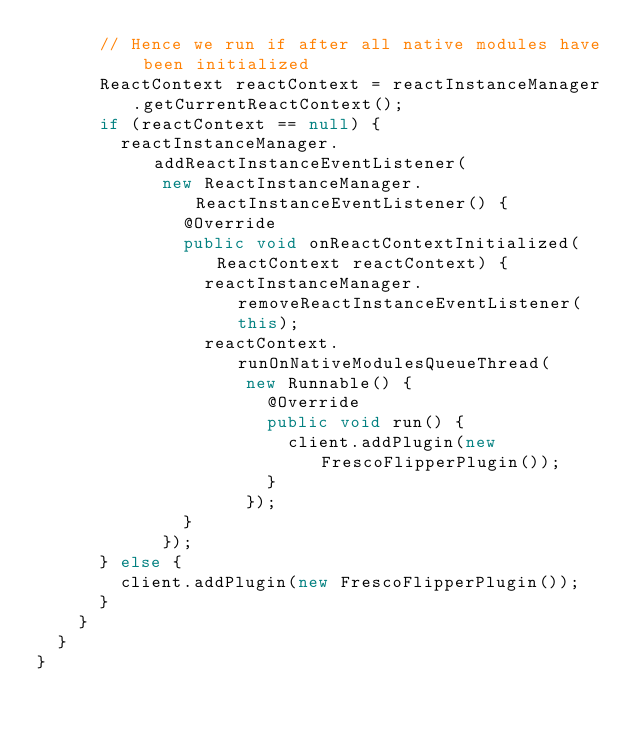Convert code to text. <code><loc_0><loc_0><loc_500><loc_500><_Java_>      // Hence we run if after all native modules have been initialized
      ReactContext reactContext = reactInstanceManager.getCurrentReactContext();
      if (reactContext == null) {
        reactInstanceManager.addReactInstanceEventListener(
            new ReactInstanceManager.ReactInstanceEventListener() {
              @Override
              public void onReactContextInitialized(ReactContext reactContext) {
                reactInstanceManager.removeReactInstanceEventListener(this);
                reactContext.runOnNativeModulesQueueThread(
                    new Runnable() {
                      @Override
                      public void run() {
                        client.addPlugin(new FrescoFlipperPlugin());
                      }
                    });
              }
            });
      } else {
        client.addPlugin(new FrescoFlipperPlugin());
      }
    }
  }
}
</code> 